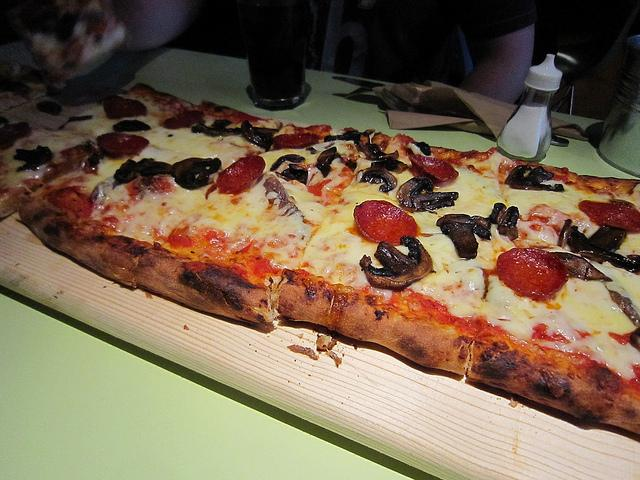What ingredient used as a veg toppings of the pizza? Please explain your reasoning. mushroom. This pizza has meat toppings but the only vegetable topping is mushrooms. 